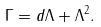Convert formula to latex. <formula><loc_0><loc_0><loc_500><loc_500>\Gamma = d \Lambda + \Lambda ^ { 2 } .</formula> 